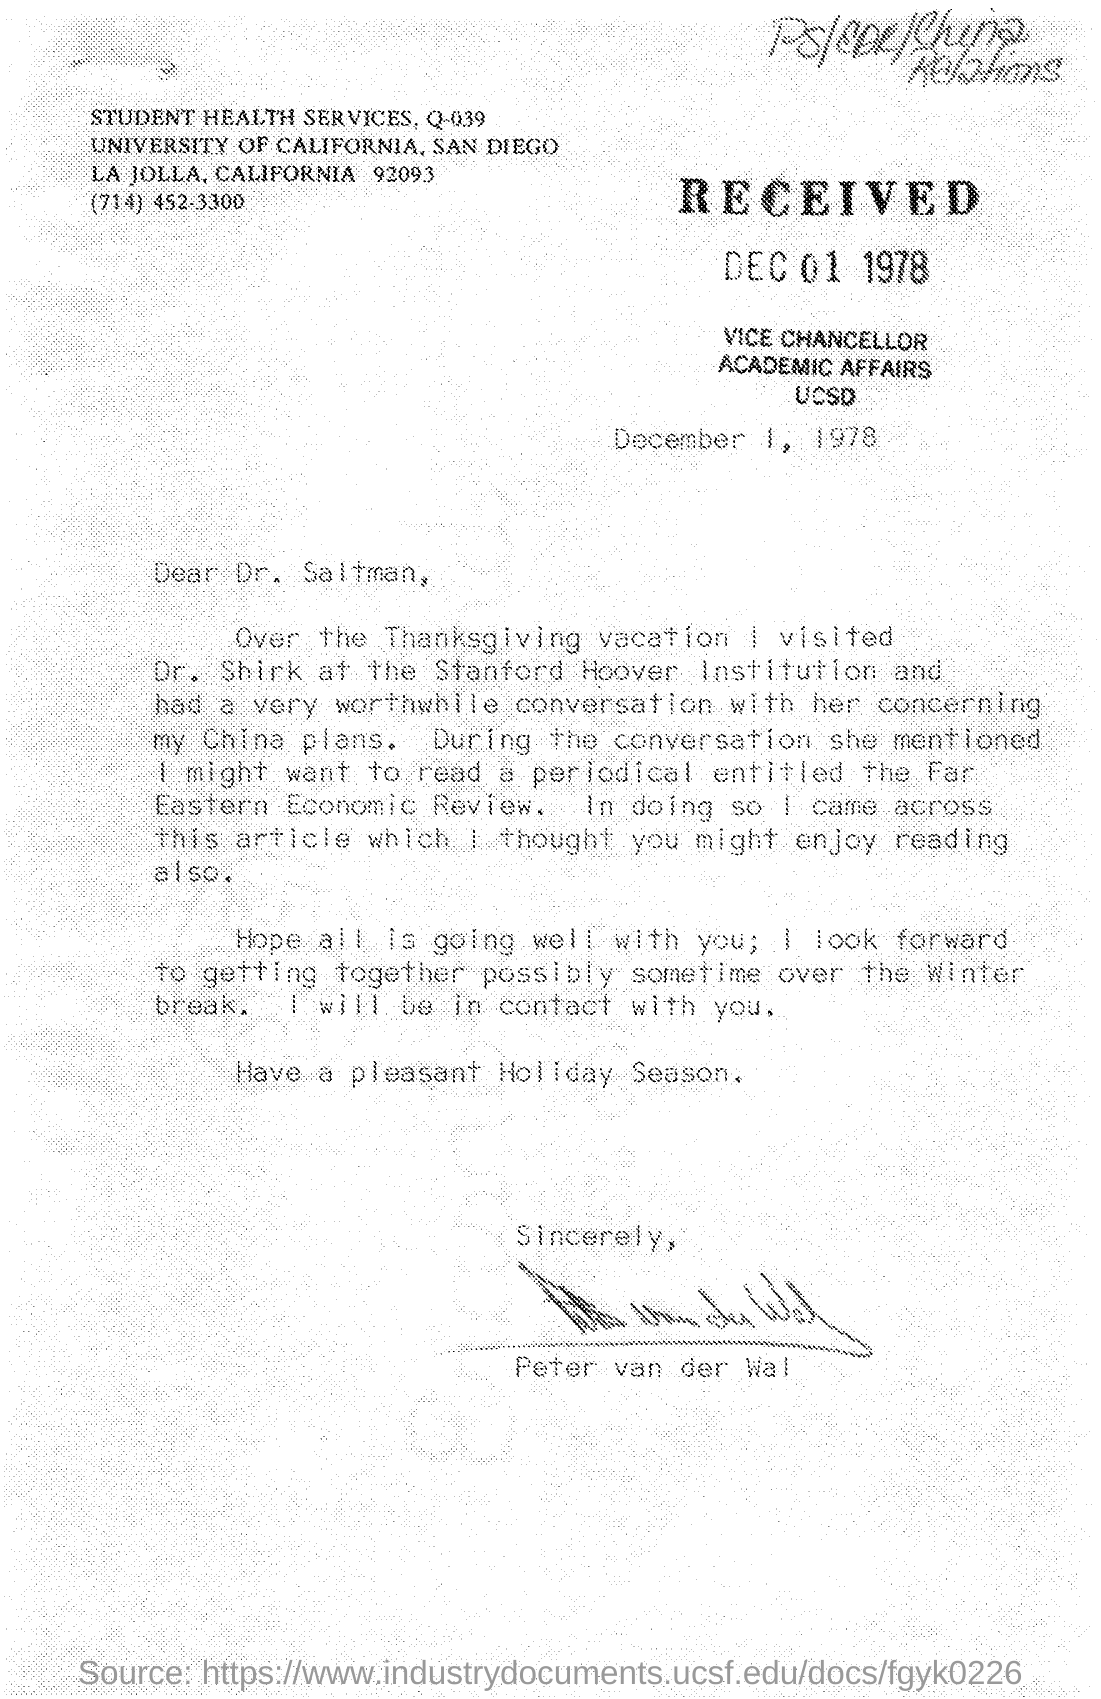Draw attention to some important aspects in this diagram. The University of California is mentioned in the given letter. The letter was written on December 1, 1978. The services mentioned in the given letter are named 'student health services,' and they are identified as Q-039. On December 1, 1978, the letter was received. The signature at the end of the letter was that of Peter van der Wal. 